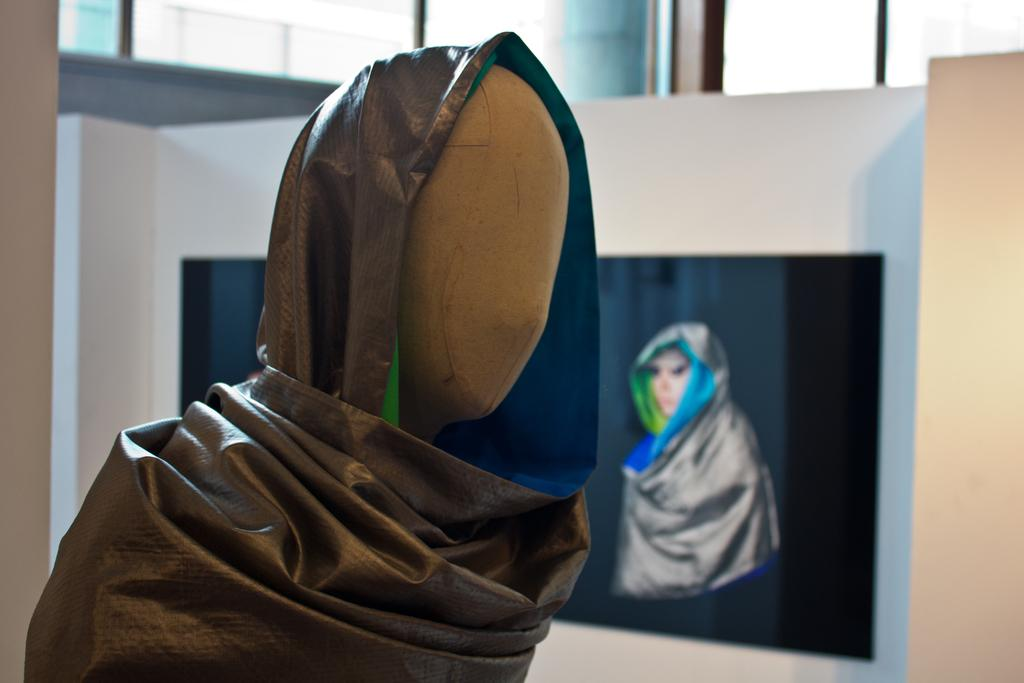What is the main subject in the image? There is a mannequin with a cloth in the image. What can be seen in the background of the image? There is a frame of a person with a cloth in the background. Where is the frame located? The frame is on a wall. What other objects are present in the image? There are rods in the image. What type of sponge is being used to play music in the image? There is no sponge or music present in the image. What ornament is hanging from the rods in the image? There is no ornament mentioned or visible in the image; only the mannequin, frame, and rods are present. 